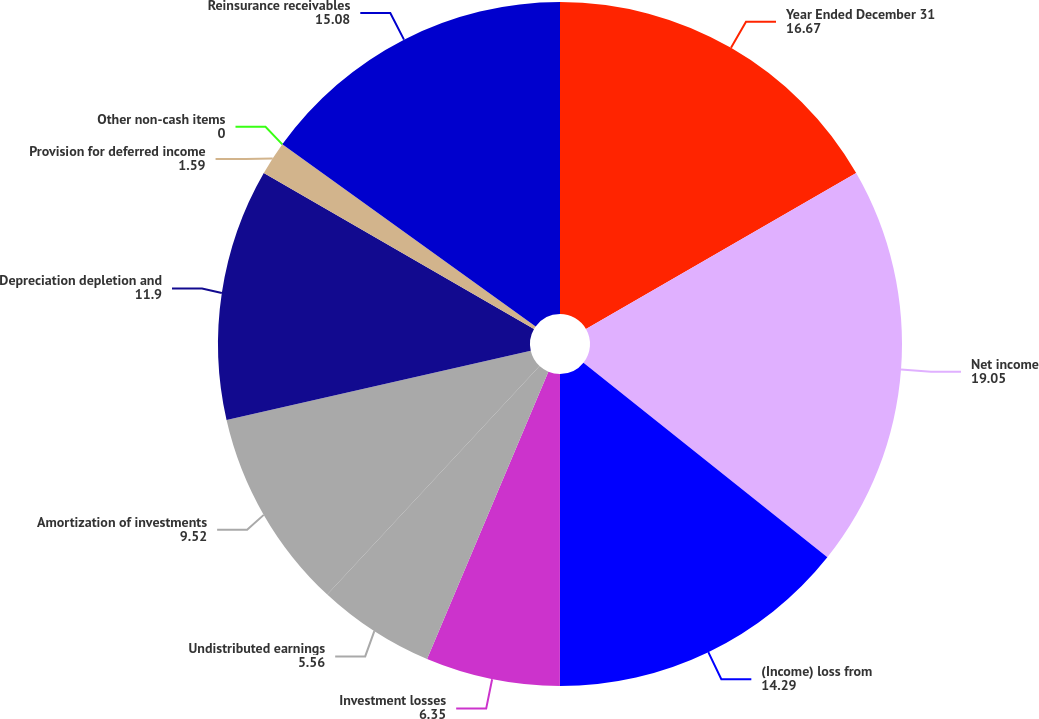Convert chart to OTSL. <chart><loc_0><loc_0><loc_500><loc_500><pie_chart><fcel>Year Ended December 31<fcel>Net income<fcel>(Income) loss from<fcel>Investment losses<fcel>Undistributed earnings<fcel>Amortization of investments<fcel>Depreciation depletion and<fcel>Provision for deferred income<fcel>Other non-cash items<fcel>Reinsurance receivables<nl><fcel>16.67%<fcel>19.05%<fcel>14.29%<fcel>6.35%<fcel>5.56%<fcel>9.52%<fcel>11.9%<fcel>1.59%<fcel>0.0%<fcel>15.08%<nl></chart> 